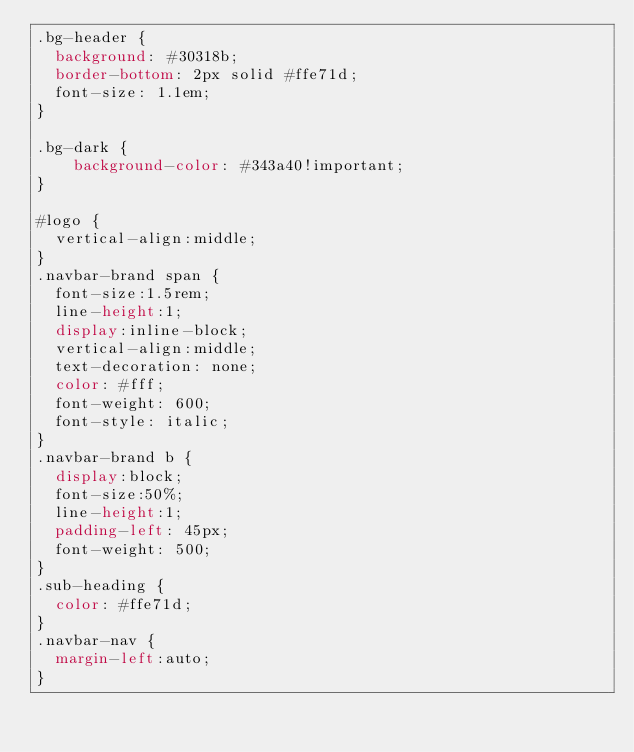<code> <loc_0><loc_0><loc_500><loc_500><_CSS_>.bg-header {
  background: #30318b;
  border-bottom: 2px solid #ffe71d;
  font-size: 1.1em;
}

.bg-dark {
    background-color: #343a40!important;
}

#logo {
	vertical-align:middle;
}
.navbar-brand span {
	font-size:1.5rem;
	line-height:1;
	display:inline-block;
	vertical-align:middle;
  text-decoration: none;
  color: #fff;
  font-weight: 600;
  font-style: italic;
}
.navbar-brand b {
	display:block;
	font-size:50%;
	line-height:1;
  padding-left: 45px;
  font-weight: 500;
}
.sub-heading {
	color: #ffe71d;
}
.navbar-nav {
	margin-left:auto;
}
</code> 